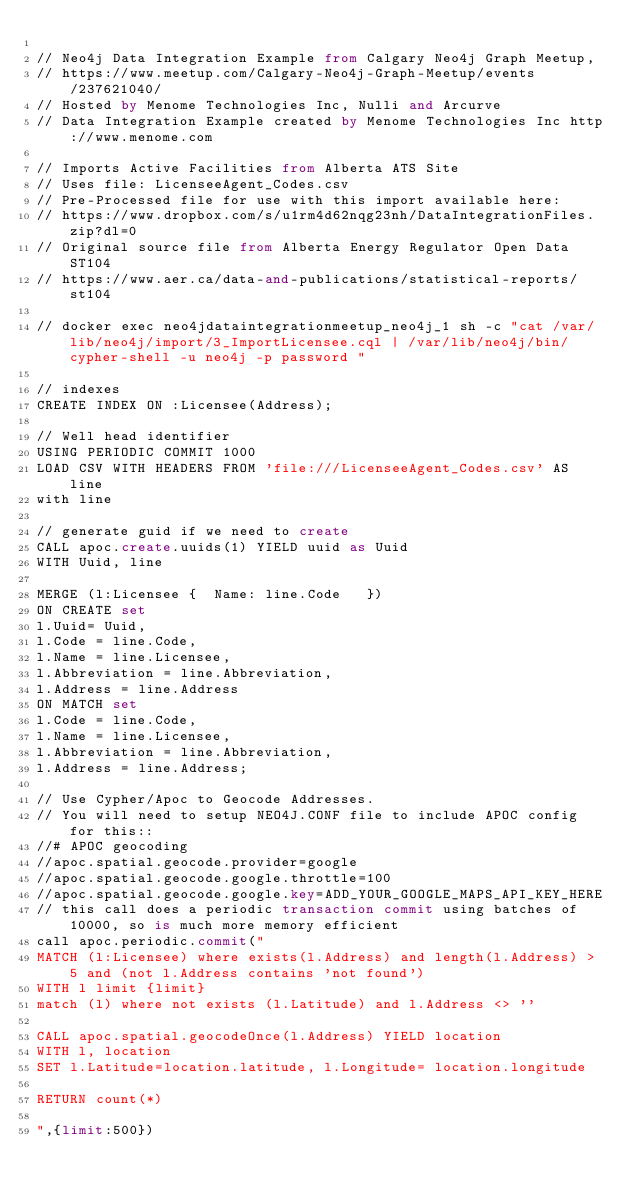<code> <loc_0><loc_0><loc_500><loc_500><_SQL_>
// Neo4j Data Integration Example from Calgary Neo4j Graph Meetup, 
// https://www.meetup.com/Calgary-Neo4j-Graph-Meetup/events/237621040/
// Hosted by Menome Technologies Inc, Nulli and Arcurve
// Data Integration Example created by Menome Technologies Inc http://www.menome.com

// Imports Active Facilities from Alberta ATS Site 
// Uses file: LicenseeAgent_Codes.csv
// Pre-Processed file for use with this import available here:
// https://www.dropbox.com/s/u1rm4d62nqg23nh/DataIntegrationFiles.zip?dl=0
// Original source file from Alberta Energy Regulator Open Data ST104
// https://www.aer.ca/data-and-publications/statistical-reports/st104

// docker exec neo4jdataintegrationmeetup_neo4j_1 sh -c "cat /var/lib/neo4j/import/3_ImportLicensee.cql | /var/lib/neo4j/bin/cypher-shell -u neo4j -p password "

// indexes
CREATE INDEX ON :Licensee(Address);

// Well head identifier
USING PERIODIC COMMIT 1000
LOAD CSV WITH HEADERS FROM 'file:///LicenseeAgent_Codes.csv' AS line 
with line

// generate guid if we need to create
CALL apoc.create.uuids(1) YIELD uuid as Uuid
WITH Uuid, line

MERGE (l:Licensee {  Name: line.Code   })
ON CREATE set
l.Uuid= Uuid,
l.Code = line.Code,
l.Name = line.Licensee,
l.Abbreviation = line.Abbreviation,
l.Address = line.Address
ON MATCH set
l.Code = line.Code,
l.Name = line.Licensee,
l.Abbreviation = line.Abbreviation,
l.Address = line.Address;

// Use Cypher/Apoc to Geocode Addresses. 
// You will need to setup NEO4J.CONF file to include APOC config for this::
//# APOC geocoding
//apoc.spatial.geocode.provider=google
//apoc.spatial.geocode.google.throttle=100
//apoc.spatial.geocode.google.key=ADD_YOUR_GOOGLE_MAPS_API_KEY_HERE
// this call does a periodic transaction commit using batches of 10000, so is much more memory efficient
call apoc.periodic.commit("
MATCH (l:Licensee) where exists(l.Address) and length(l.Address) > 5 and (not l.Address contains 'not found') 
WITH l limit {limit}
match (l) where not exists (l.Latitude) and l.Address <> '' 

CALL apoc.spatial.geocodeOnce(l.Address) YIELD location
WITH l, location
SET l.Latitude=location.latitude, l.Longitude= location.longitude

RETURN count(*)

",{limit:500})
</code> 